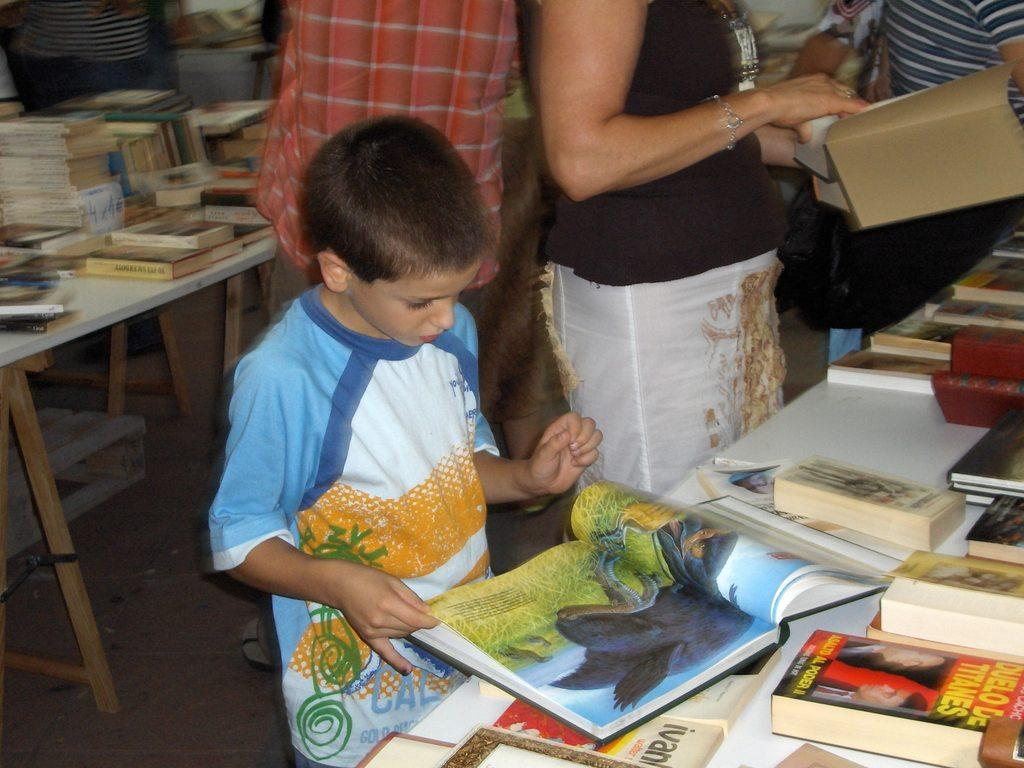What are the people in the image holding? The people in the image are holding books. Can you describe the setting in the image? The setting in the image includes people holding books and books on a table in the background. What type of wound can be seen on the book in the image? There is no wound present on the book in the image; it is a book, not a living organism that can be wounded. 